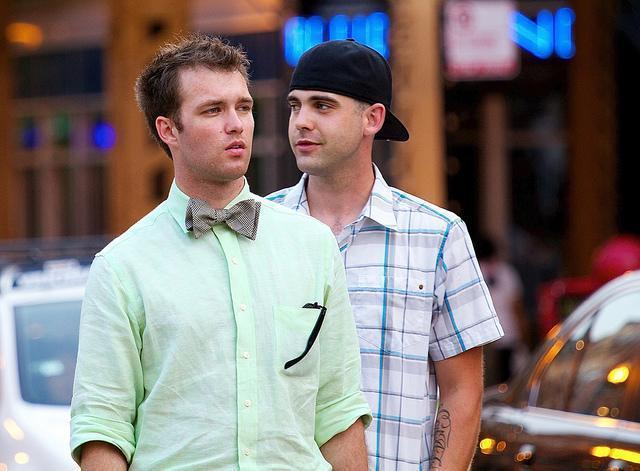How many cars can be seen?
Give a very brief answer. 2. How many people are visible?
Give a very brief answer. 2. 